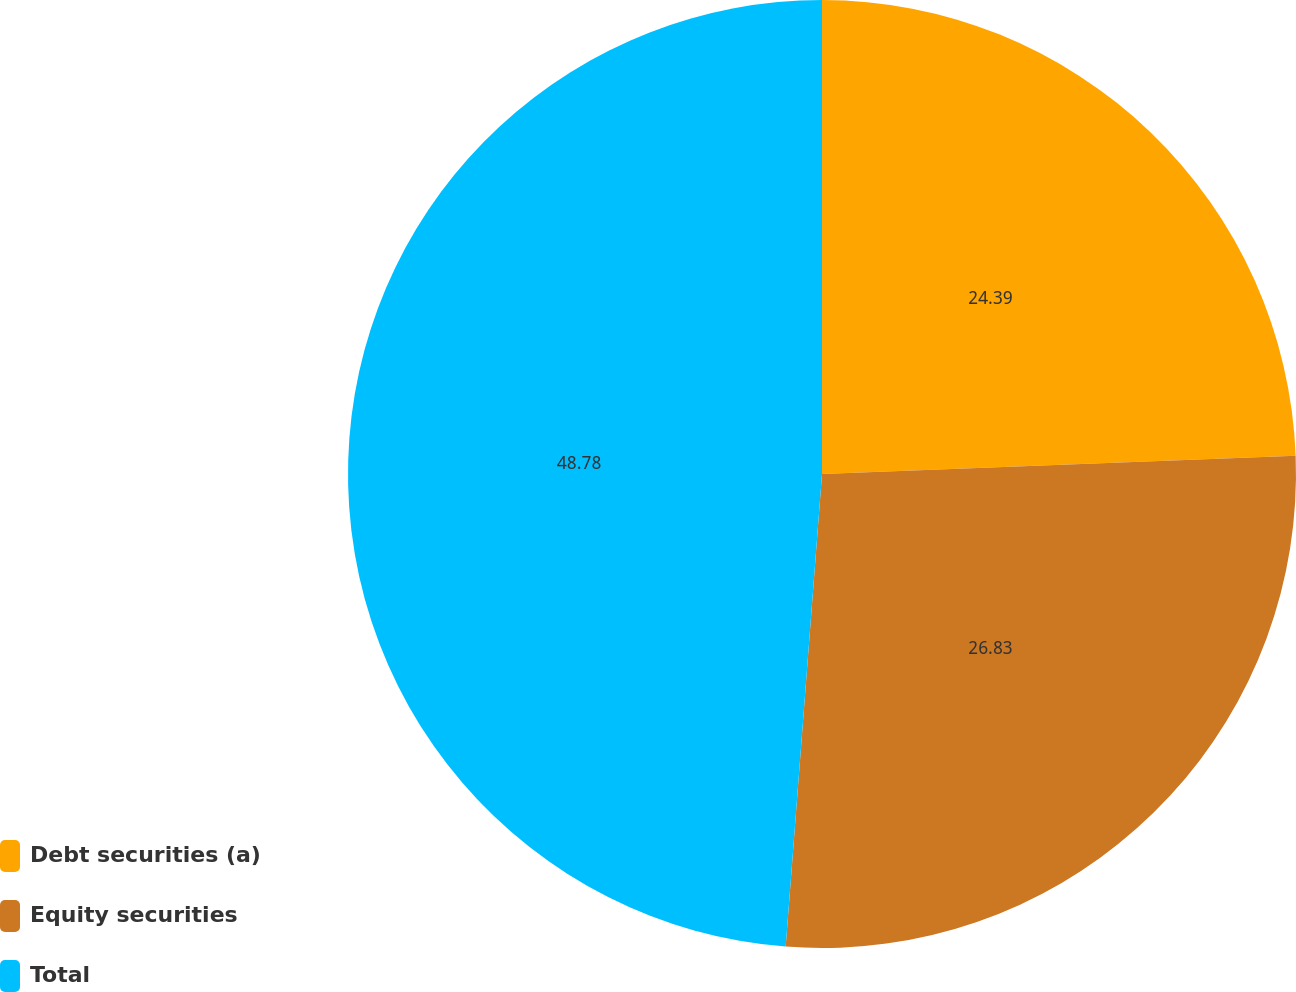<chart> <loc_0><loc_0><loc_500><loc_500><pie_chart><fcel>Debt securities (a)<fcel>Equity securities<fcel>Total<nl><fcel>24.39%<fcel>26.83%<fcel>48.78%<nl></chart> 